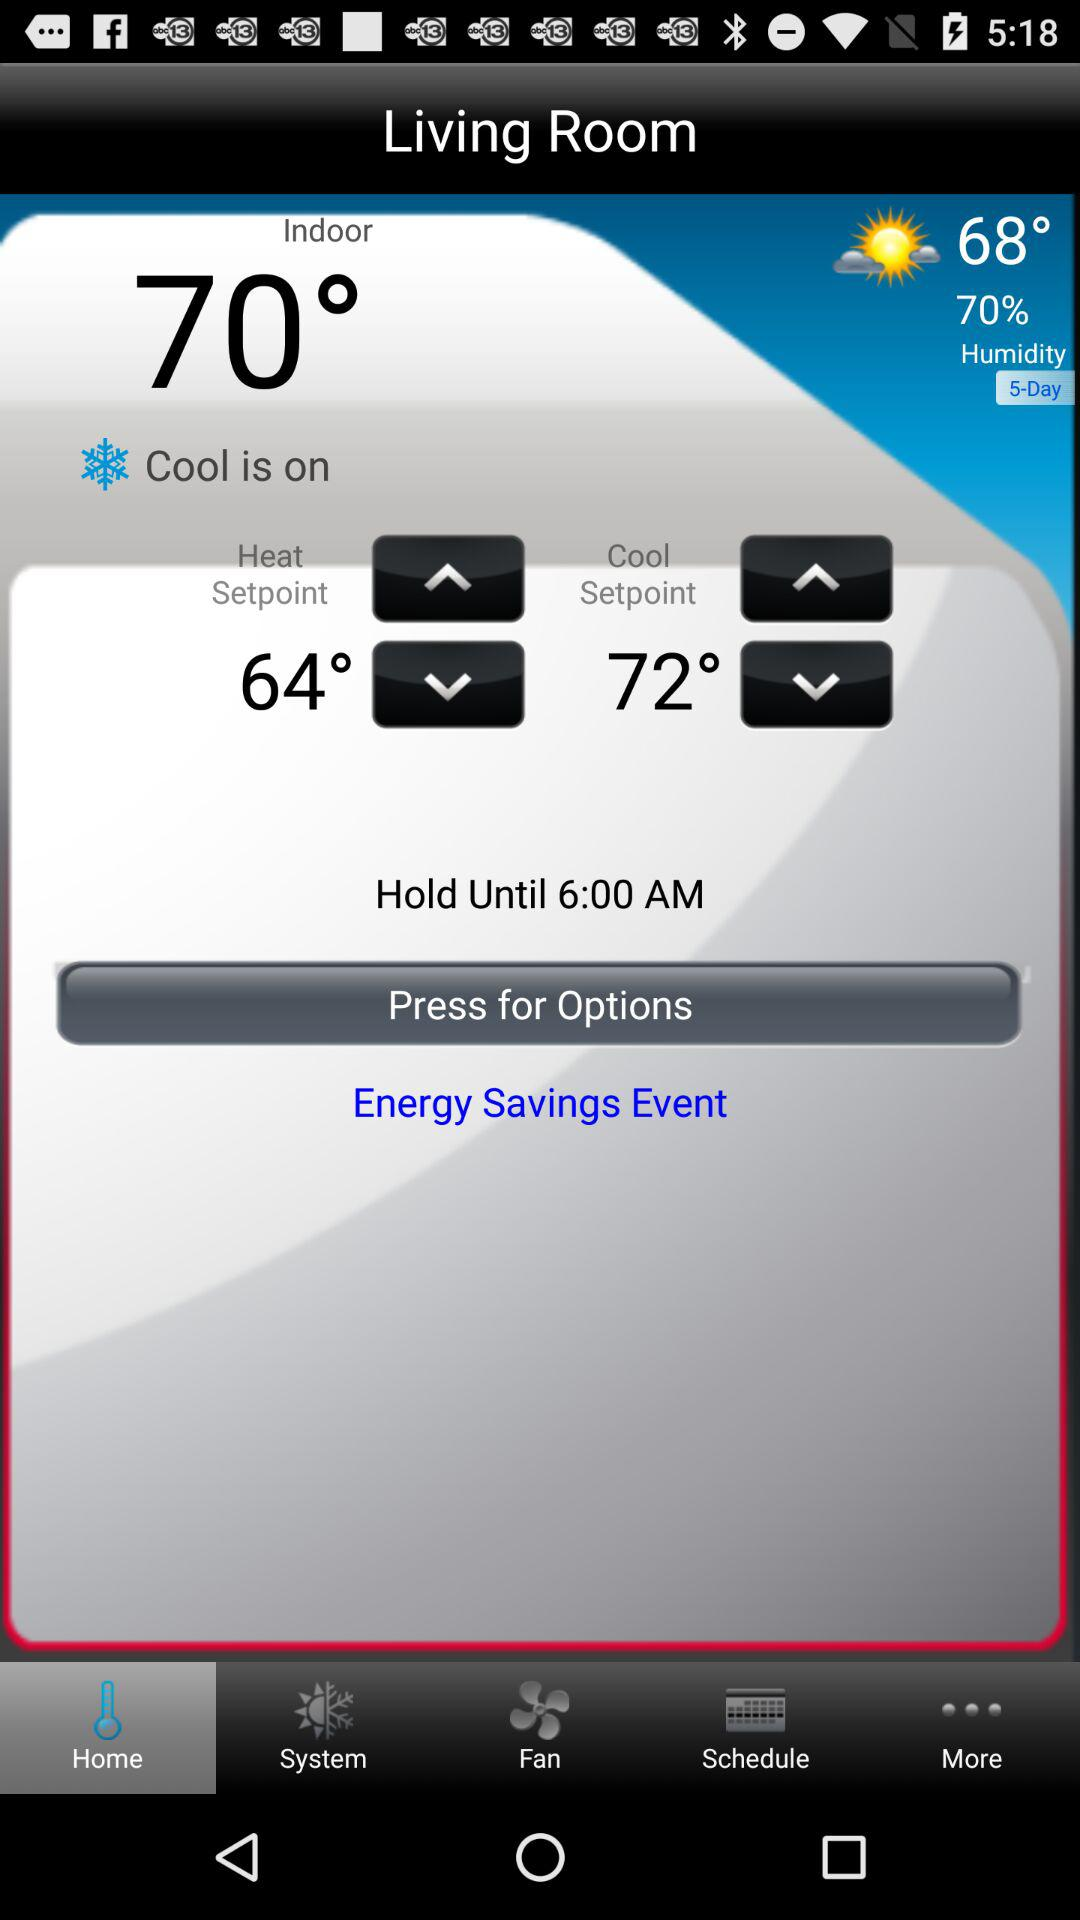What is the cooling set point? The cooling set point is 72°. 